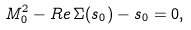Convert formula to latex. <formula><loc_0><loc_0><loc_500><loc_500>M _ { 0 } ^ { 2 } - R e \, \Sigma ( s _ { 0 } ) - s _ { 0 } = 0 ,</formula> 